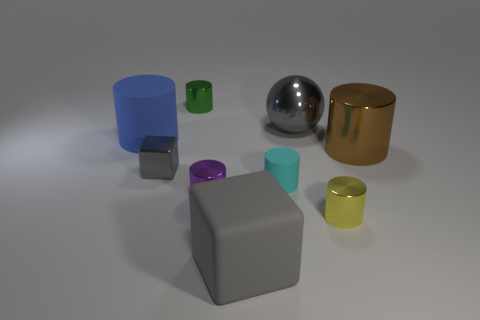Subtract 2 cylinders. How many cylinders are left? 4 Subtract all purple cylinders. How many cylinders are left? 5 Subtract all tiny yellow metal cylinders. How many cylinders are left? 5 Subtract all purple cylinders. Subtract all red balls. How many cylinders are left? 5 Add 1 small blue matte balls. How many objects exist? 10 Subtract all spheres. How many objects are left? 8 Add 7 small cyan objects. How many small cyan objects exist? 8 Subtract 0 yellow cubes. How many objects are left? 9 Subtract all tiny purple cylinders. Subtract all metallic cylinders. How many objects are left? 4 Add 6 blue rubber things. How many blue rubber things are left? 7 